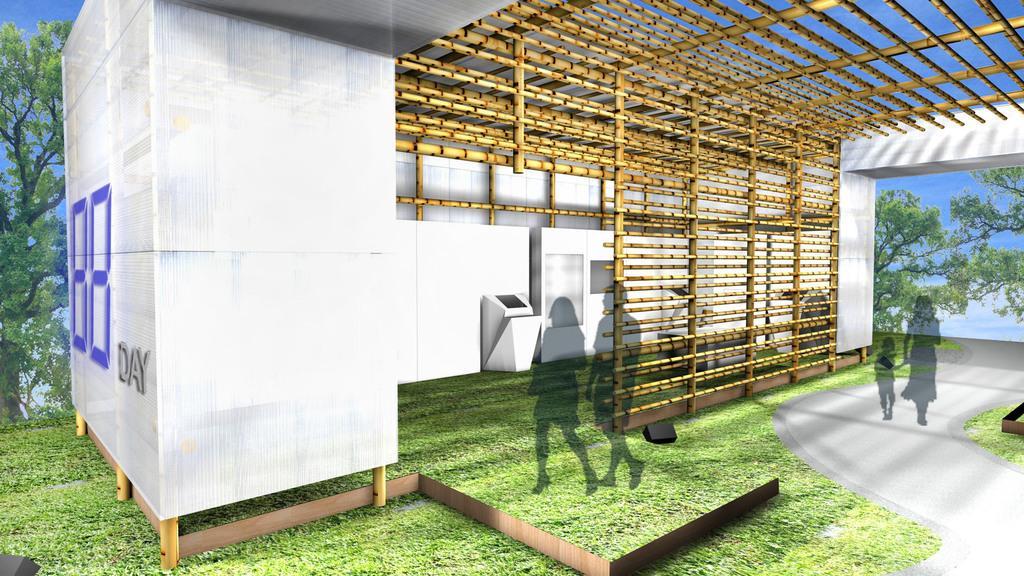Can you describe this image briefly? In this image, we can see a shed and in the background, there are trees and we can see shadows. At the bottom, there is a road and ground and at the top, there is a roof. 